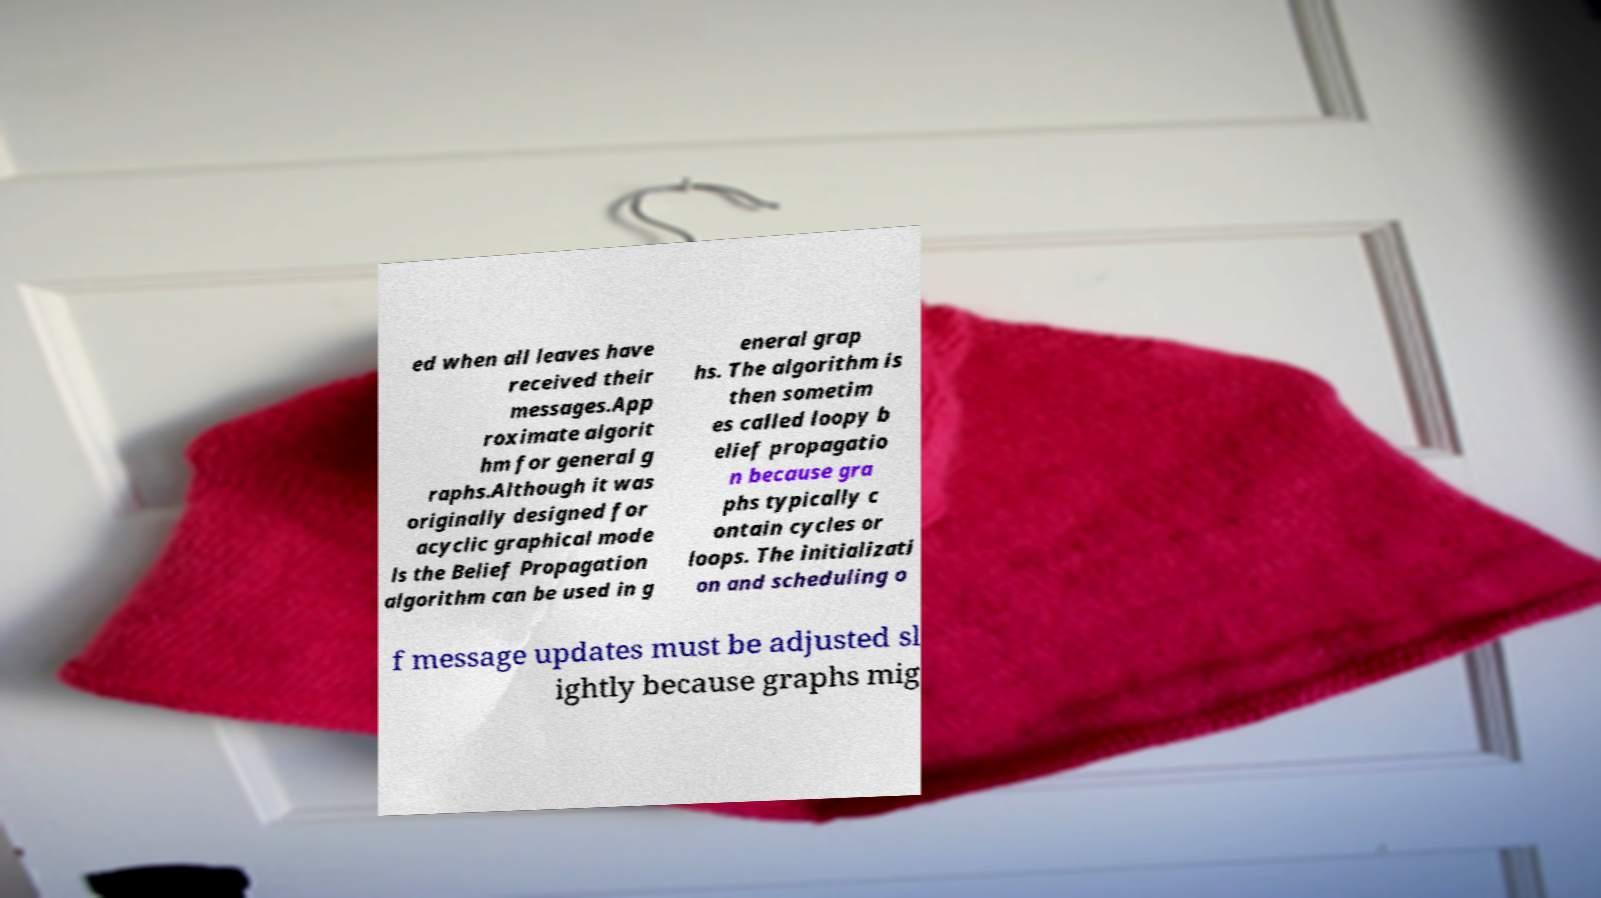What messages or text are displayed in this image? I need them in a readable, typed format. ed when all leaves have received their messages.App roximate algorit hm for general g raphs.Although it was originally designed for acyclic graphical mode ls the Belief Propagation algorithm can be used in g eneral grap hs. The algorithm is then sometim es called loopy b elief propagatio n because gra phs typically c ontain cycles or loops. The initializati on and scheduling o f message updates must be adjusted sl ightly because graphs mig 